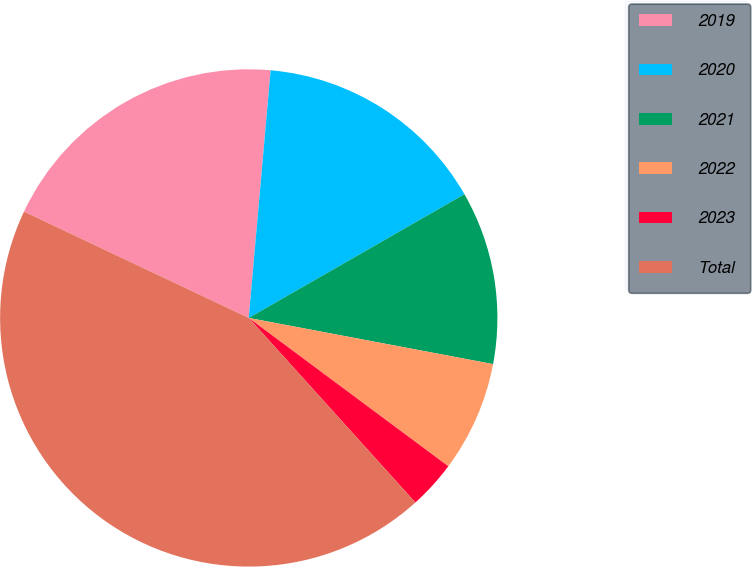<chart> <loc_0><loc_0><loc_500><loc_500><pie_chart><fcel>2019<fcel>2020<fcel>2021<fcel>2022<fcel>2023<fcel>Total<nl><fcel>19.37%<fcel>15.31%<fcel>11.26%<fcel>7.2%<fcel>3.14%<fcel>43.72%<nl></chart> 